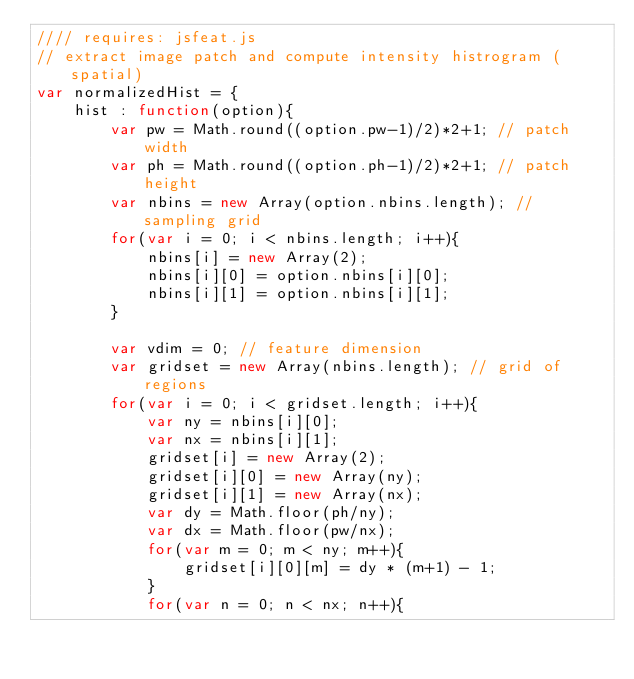<code> <loc_0><loc_0><loc_500><loc_500><_JavaScript_>//// requires: jsfeat.js
// extract image patch and compute intensity histrogram (spatial)
var normalizedHist = {
	hist : function(option){
		var pw = Math.round((option.pw-1)/2)*2+1; // patch width
		var ph = Math.round((option.ph-1)/2)*2+1; // patch height
		var nbins = new Array(option.nbins.length); // sampling grid
		for(var i = 0; i < nbins.length; i++){
			nbins[i] = new Array(2);
			nbins[i][0] = option.nbins[i][0];
			nbins[i][1] = option.nbins[i][1];
		}
		
		var vdim = 0; // feature dimension
		var gridset = new Array(nbins.length); // grid of regions
		for(var i = 0; i < gridset.length; i++){
			var ny = nbins[i][0];
			var nx = nbins[i][1];
			gridset[i] = new Array(2);
			gridset[i][0] = new Array(ny);
			gridset[i][1] = new Array(nx);
			var dy = Math.floor(ph/ny);
			var dx = Math.floor(pw/nx);
			for(var m = 0; m < ny; m++){
				gridset[i][0][m] = dy * (m+1) - 1;
			}
			for(var n = 0; n < nx; n++){</code> 